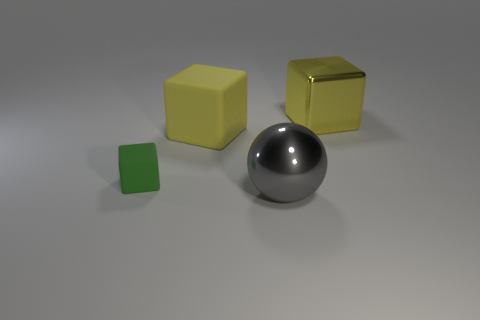Add 2 big gray objects. How many objects exist? 6 Subtract all cubes. How many objects are left? 1 Subtract all large yellow metal things. Subtract all brown spheres. How many objects are left? 3 Add 1 tiny matte blocks. How many tiny matte blocks are left? 2 Add 4 yellow shiny spheres. How many yellow shiny spheres exist? 4 Subtract 0 cyan cubes. How many objects are left? 4 